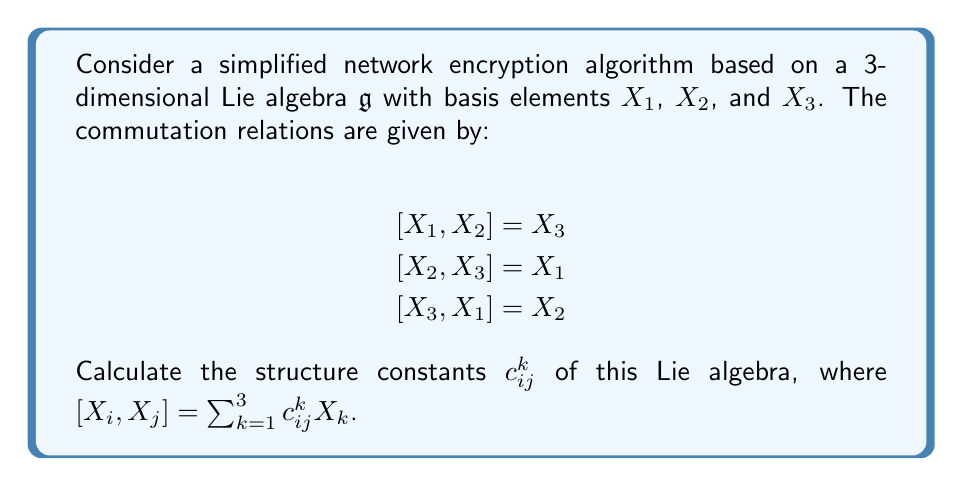Can you answer this question? To solve this problem, we need to understand the concept of structure constants in Lie algebras and how they relate to the given commutation relations. The structure constants $c_{ij}^k$ are defined by the equation:

$$[X_i, X_j] = \sum_{k=1}^3 c_{ij}^k X_k$$

Let's analyze each commutation relation:

1. For $[X_1, X_2] = X_3$:
   This implies $c_{12}^3 = 1$, and all other $c_{12}^k = 0$.

2. For $[X_2, X_3] = X_1$:
   This implies $c_{23}^1 = 1$, and all other $c_{23}^k = 0$.

3. For $[X_3, X_1] = X_2$:
   This implies $c_{31}^2 = 1$, and all other $c_{31}^k = 0$.

Now, we need to consider the anti-symmetry property of Lie brackets:
$$[X_i, X_j] = -[X_j, X_i]$$

This means that:
$$c_{ij}^k = -c_{ji}^k$$

Therefore:
- $c_{21}^3 = -1$ (from $c_{12}^3 = 1$)
- $c_{32}^1 = -1$ (from $c_{23}^1 = 1$)
- $c_{13}^2 = -1$ (from $c_{31}^2 = 1$)

All other structure constants are zero.

To summarize, the non-zero structure constants are:
$$c_{12}^3 = c_{23}^1 = c_{31}^2 = 1$$
$$c_{21}^3 = c_{32}^1 = c_{13}^2 = -1$$
Answer: The non-zero structure constants of the given Lie algebra are:
$$c_{12}^3 = c_{23}^1 = c_{31}^2 = 1$$
$$c_{21}^3 = c_{32}^1 = c_{13}^2 = -1$$
All other structure constants are zero. 